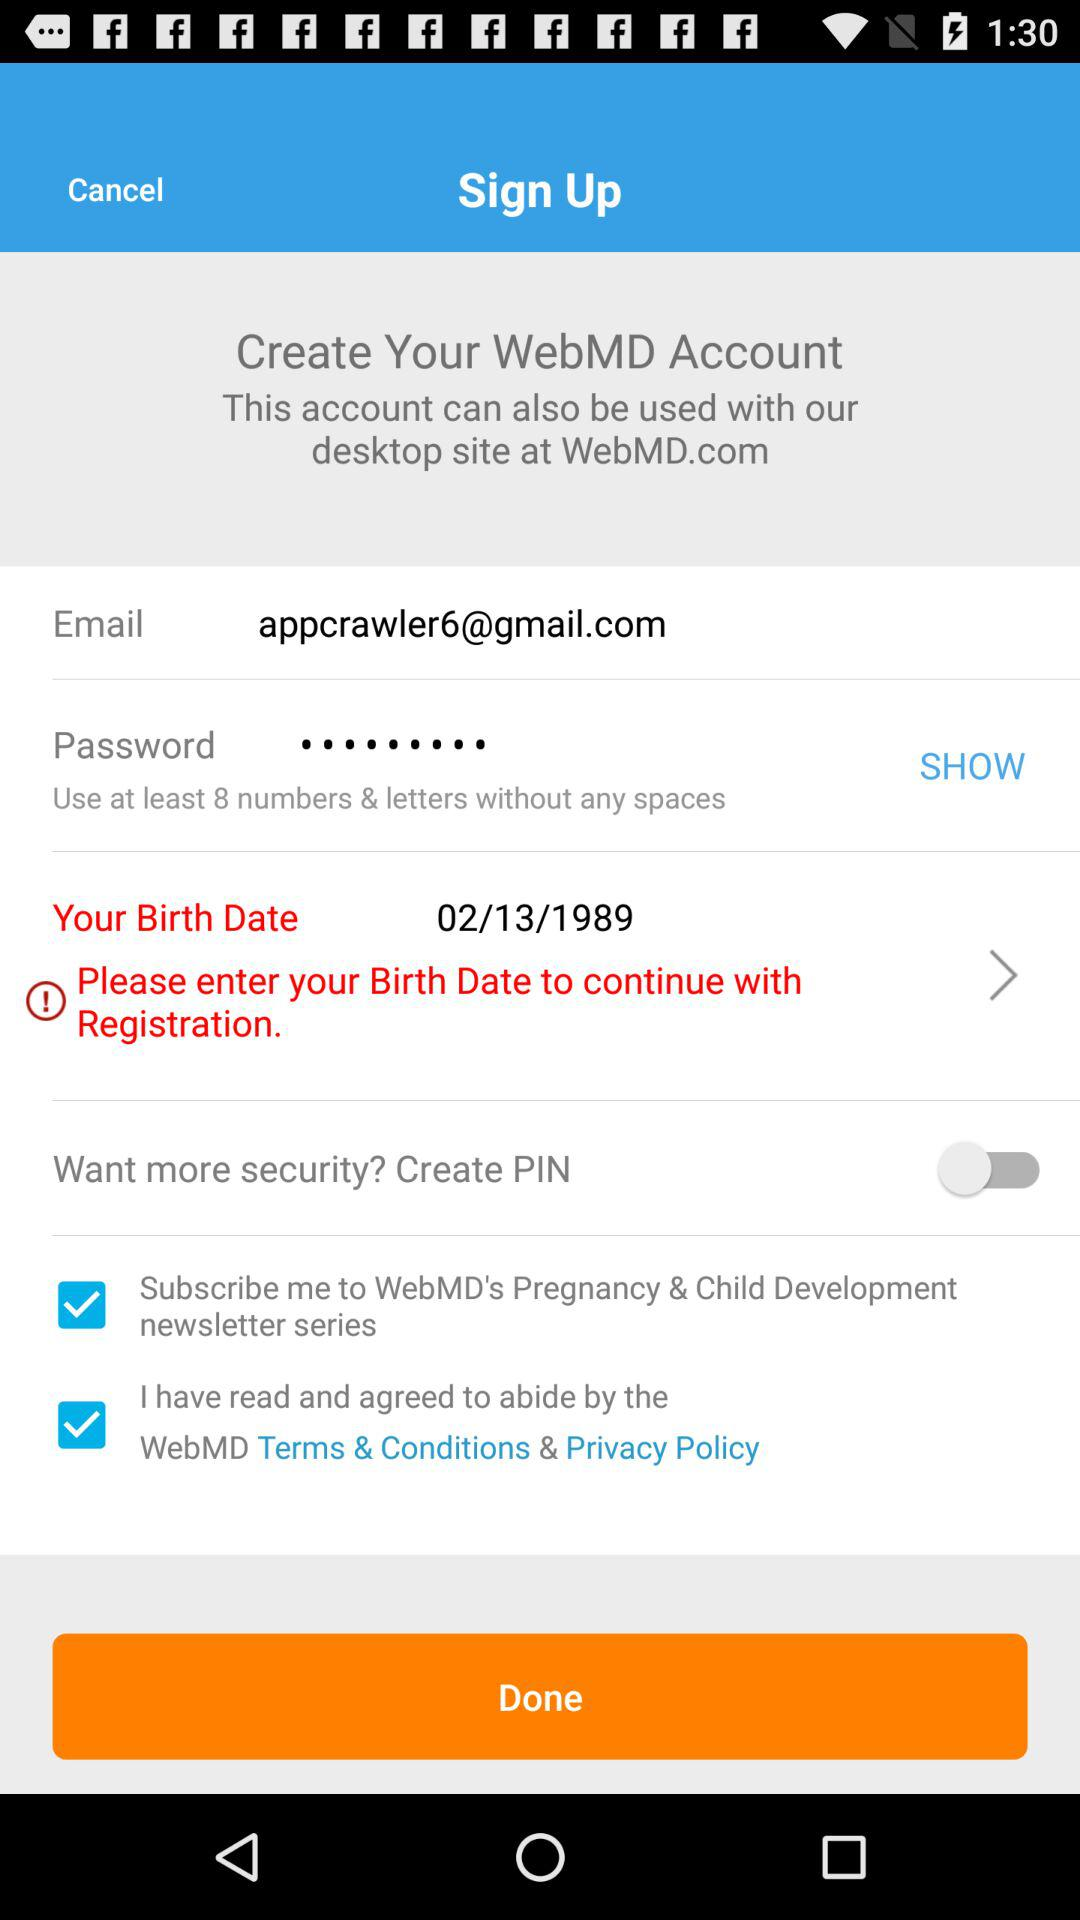What is the status of the "Want more security? Create PIN"? The status is "off". 